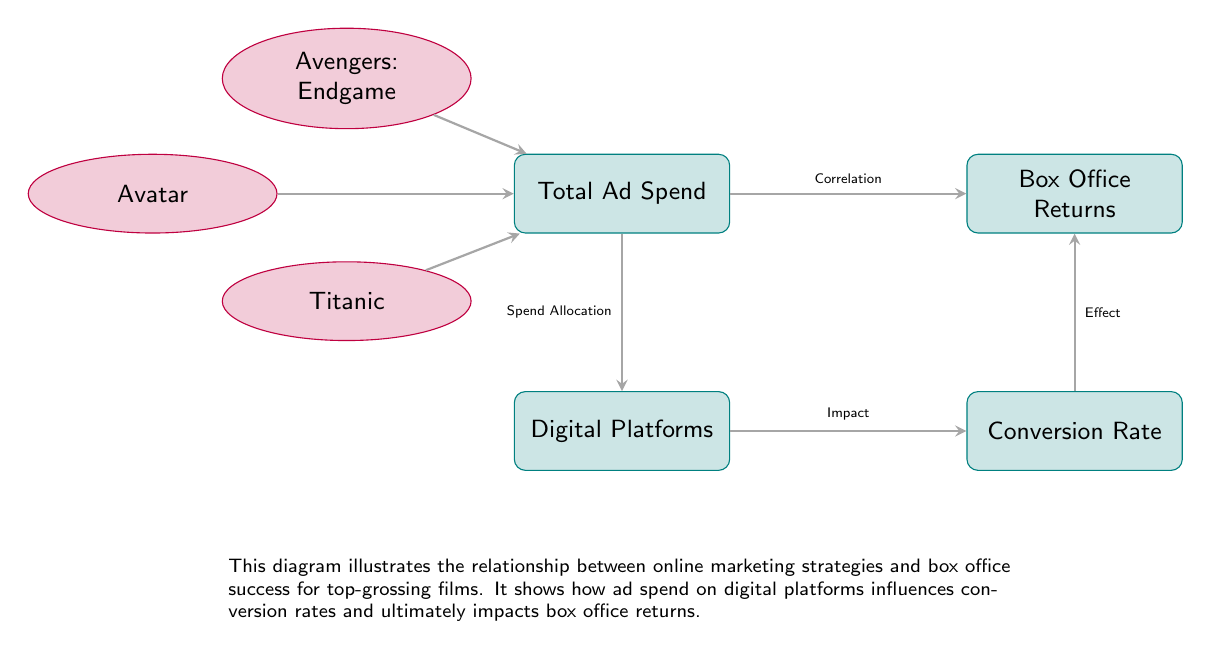What is the total number of nodes in the diagram? The diagram features five distinct nodes: three film nodes (Avatar, Avengers: Endgame, Titanic) and two box nodes (Total Ad Spend, Box Office Returns). Adding these together gives a total of five nodes.
Answer: 5 What does the arrow between Total Ad Spend and Box Office Returns indicate? The arrow signifies a correlation between Total Ad Spend and Box Office Returns, indicating that the amount spent on advertising is related to how much money the film brings in at the box office.
Answer: Correlation Which film node is connected to Total Ad Spend? All three film nodes (Avatar, Avengers: Endgame, Titanic) are connected to the Total Ad Spend node, meaning they each relate to advertising expenditure in some manner.
Answer: Avatar, Avengers: Endgame, Titanic What does Spend Allocation influence in the diagram? Spend Allocation impacts Digital Platforms, showing that how ad spend is divided among platforms can have an effect on which platforms receive more investment for marketing campaigns.
Answer: Digital Platforms Trace a path from Digital Platforms to Box Office Returns. What is this path? The path starts at Digital Platforms, leading to Conversion Rate, and then from Conversion Rate to Box Office Returns. This sequence indicates that the efficiency of spending on different platforms influences conversion, which subsequently affects box office earnings.
Answer: Digital Platforms → Conversion Rate → Box Office Returns What is the relationship between Conversion Rate and Box Office Returns? The diagram indicates that Conversion Rate has an effect on Box Office Returns. This suggests that a higher conversion rate from marketing strategies can lead to increased box office income.
Answer: Effect How many edges (arrows) are present in the illustration? There are five edges depicted, connecting the nodes: Total Ad Spend to Box Office Returns, Total Ad Spend to Digital Platforms, Digital Platforms to Conversion Rate, Conversion Rate to Box Office Returns, and each film node to Total Ad Spend.
Answer: 5 Which node is the starting point for the arrows leading to the film nodes? The Total Ad Spend node serves as the starting point, as the arrows from each film node (Avatar, Avengers: Endgame, Titanic) point towards it, indicating that these films contribute to ad spending.
Answer: Total Ad Spend What is an effect mentioned in the relationship between Digital Platforms and Conversion Rate? The relationship specifies that there is an impact from Digital Platforms to Conversion Rate, suggesting that the strategy used in digital marketing leads to different levels of conversion from advertisements.
Answer: Impact 